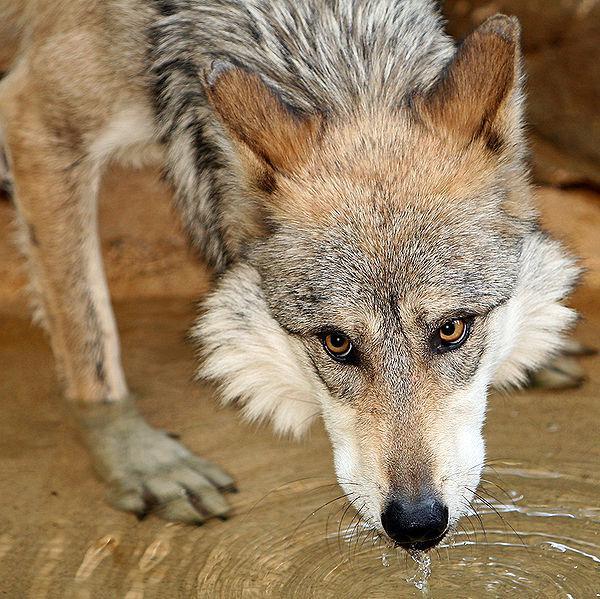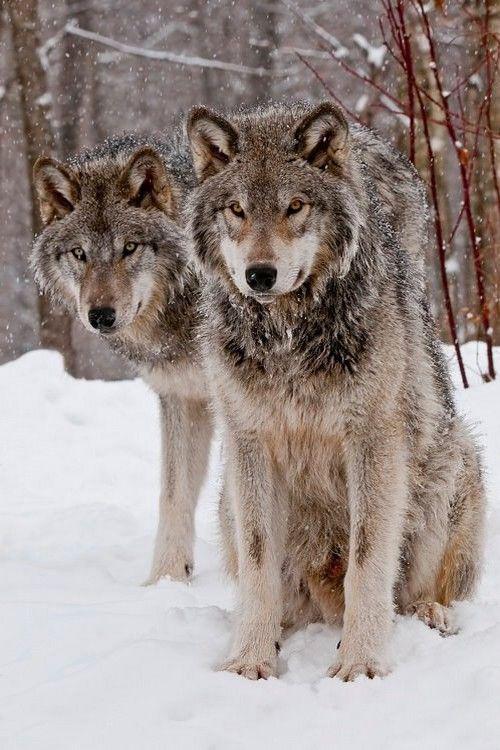The first image is the image on the left, the second image is the image on the right. Given the left and right images, does the statement "All of the images show a wolf in a standing position." hold true? Answer yes or no. No. The first image is the image on the left, the second image is the image on the right. Evaluate the accuracy of this statement regarding the images: "In the image of the wolf on the right, it appears to be autumn.". Is it true? Answer yes or no. No. 